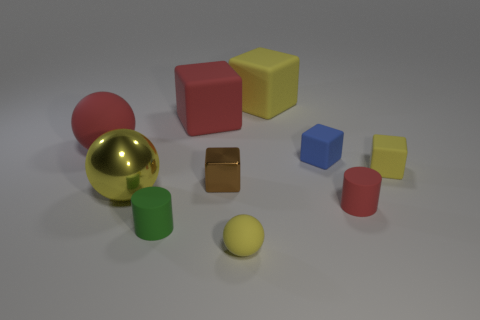How many other objects are there of the same color as the large metallic object?
Offer a very short reply. 3. How many tiny blue cubes are made of the same material as the brown thing?
Your answer should be compact. 0. Does the large matte block on the left side of the big yellow matte block have the same color as the big metal sphere?
Your response must be concise. No. How many purple objects are either tiny matte blocks or large metal objects?
Keep it short and to the point. 0. Is there any other thing that is made of the same material as the red cylinder?
Make the answer very short. Yes. Is the material of the block on the left side of the small shiny block the same as the small blue cube?
Keep it short and to the point. Yes. What number of things are either small rubber spheres or matte objects on the right side of the big red sphere?
Keep it short and to the point. 7. How many big blocks are to the left of the yellow rubber cube that is on the right side of the large yellow object behind the yellow metal ball?
Give a very brief answer. 2. Is the shape of the small yellow object that is left of the big yellow cube the same as  the green thing?
Keep it short and to the point. No. There is a yellow ball left of the red cube; are there any small brown shiny things that are in front of it?
Make the answer very short. No. 